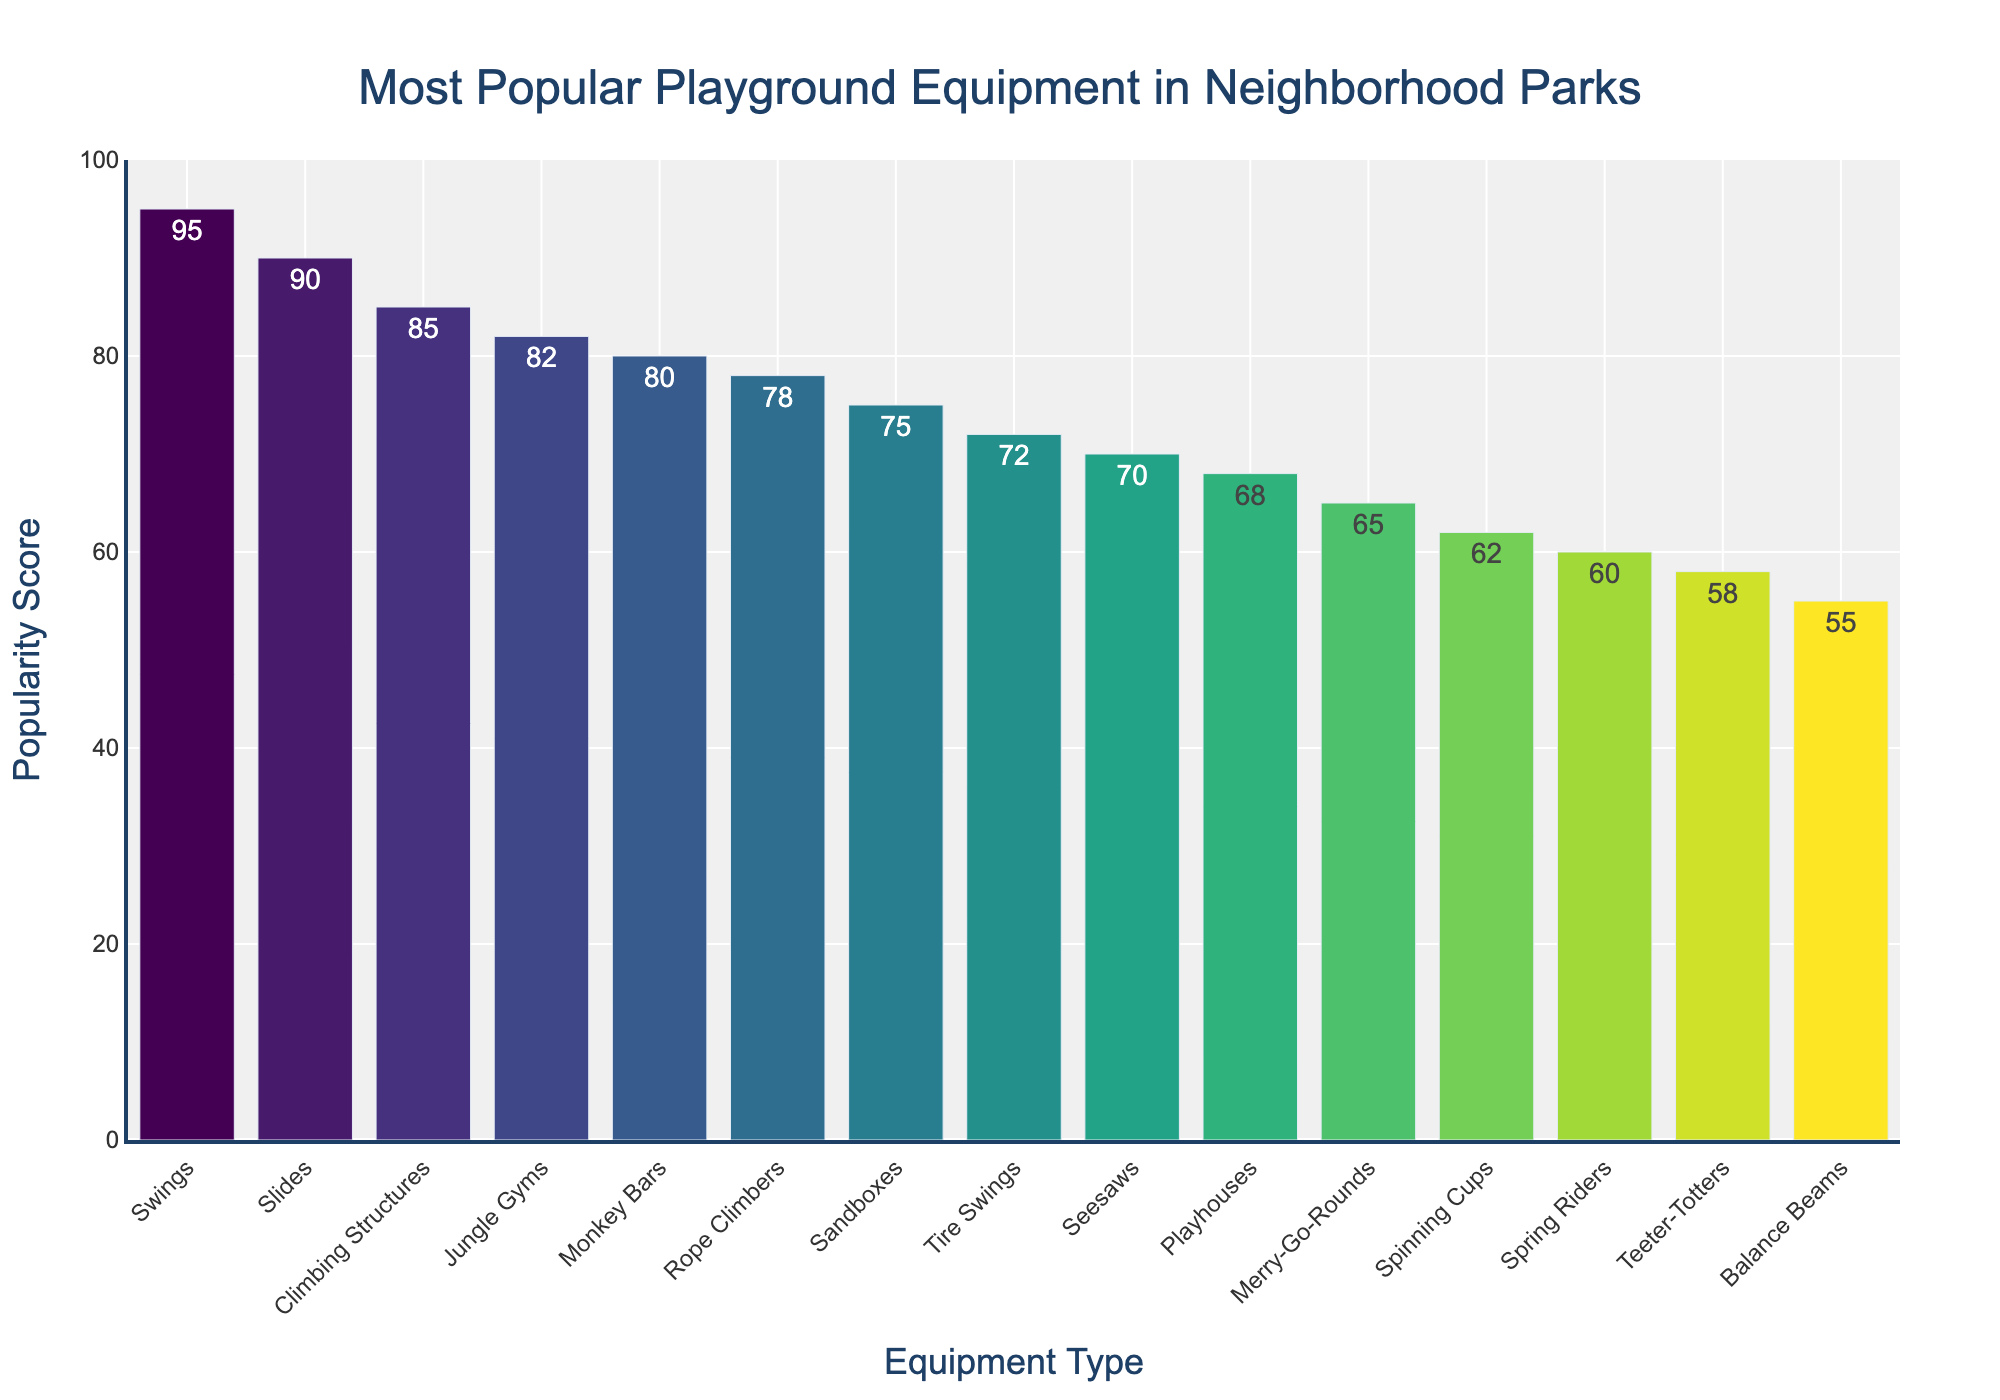Which equipment type has the highest popularity score? The highest bar in the chart represents the equipment type with the highest popularity score. By looking at the chart, the bar for "Swings" is the tallest.
Answer: Swings What is the difference in popularity scores between Swings and Slides? First, note the popularity scores for Swings (95) and Slides (90). Subtract the score of Slides from the score of Swings: 95 - 90.
Answer: 5 Which equipment types have popularity scores greater than 80? Identify bars with heights corresponding to scores above 80. These are Swings (95), Slides (90), Climbing Structures (85), and Jungle Gyms (82).
Answer: Swings, Slides, Climbing Structures, Jungle Gyms How much more popular are Seesaws compared to Spring Riders? Look at the popularity scores for Seesaws (70) and Spring Riders (60). Calculate the difference: 70 - 60.
Answer: 10 Which equipment type is less popular: Tire Swings or Playhouses? Compare the popularity scores of Tire Swings (72) and Playhouses (68). The score for Tire Swings is higher than that for Playhouses, indicating Playhouses are less popular.
Answer: Playhouses What is the median popularity score of all equipment types? List the popularity scores in ascending order: 55, 58, 60, 62, 65, 68, 70, 72, 75, 78, 80, 82, 85, 90, 95. The median is the middle value in this ordered list. The middle value (8th in this list of 15 scores) is 72.
Answer: 72 What is the average popularity score of the top 5 most popular equipment types? Identify the top 5 scores: 95 (Swings), 90 (Slides), 85 (Climbing Structures), 82 (Jungle Gyms), and 80 (Monkey Bars). Calculate the average: (95 + 90 + 85 + 82 + 80)/5 = 432/5.
Answer: 86.4 How does the popularity of Jungle Gyms compare to Rope Climbers? Compare the bars of Jungle Gyms (82) and Rope Climbers (78). The score of Jungle Gyms is higher than that of Rope Climbers.
Answer: Jungle Gyms Identify the range of popularity scores presented in the chart. The range is the difference between the highest and lowest popularity scores. The highest score is for Swings (95) and the lowest is for Balance Beams (55). Calculate the range: 95 - 55.
Answer: 40 